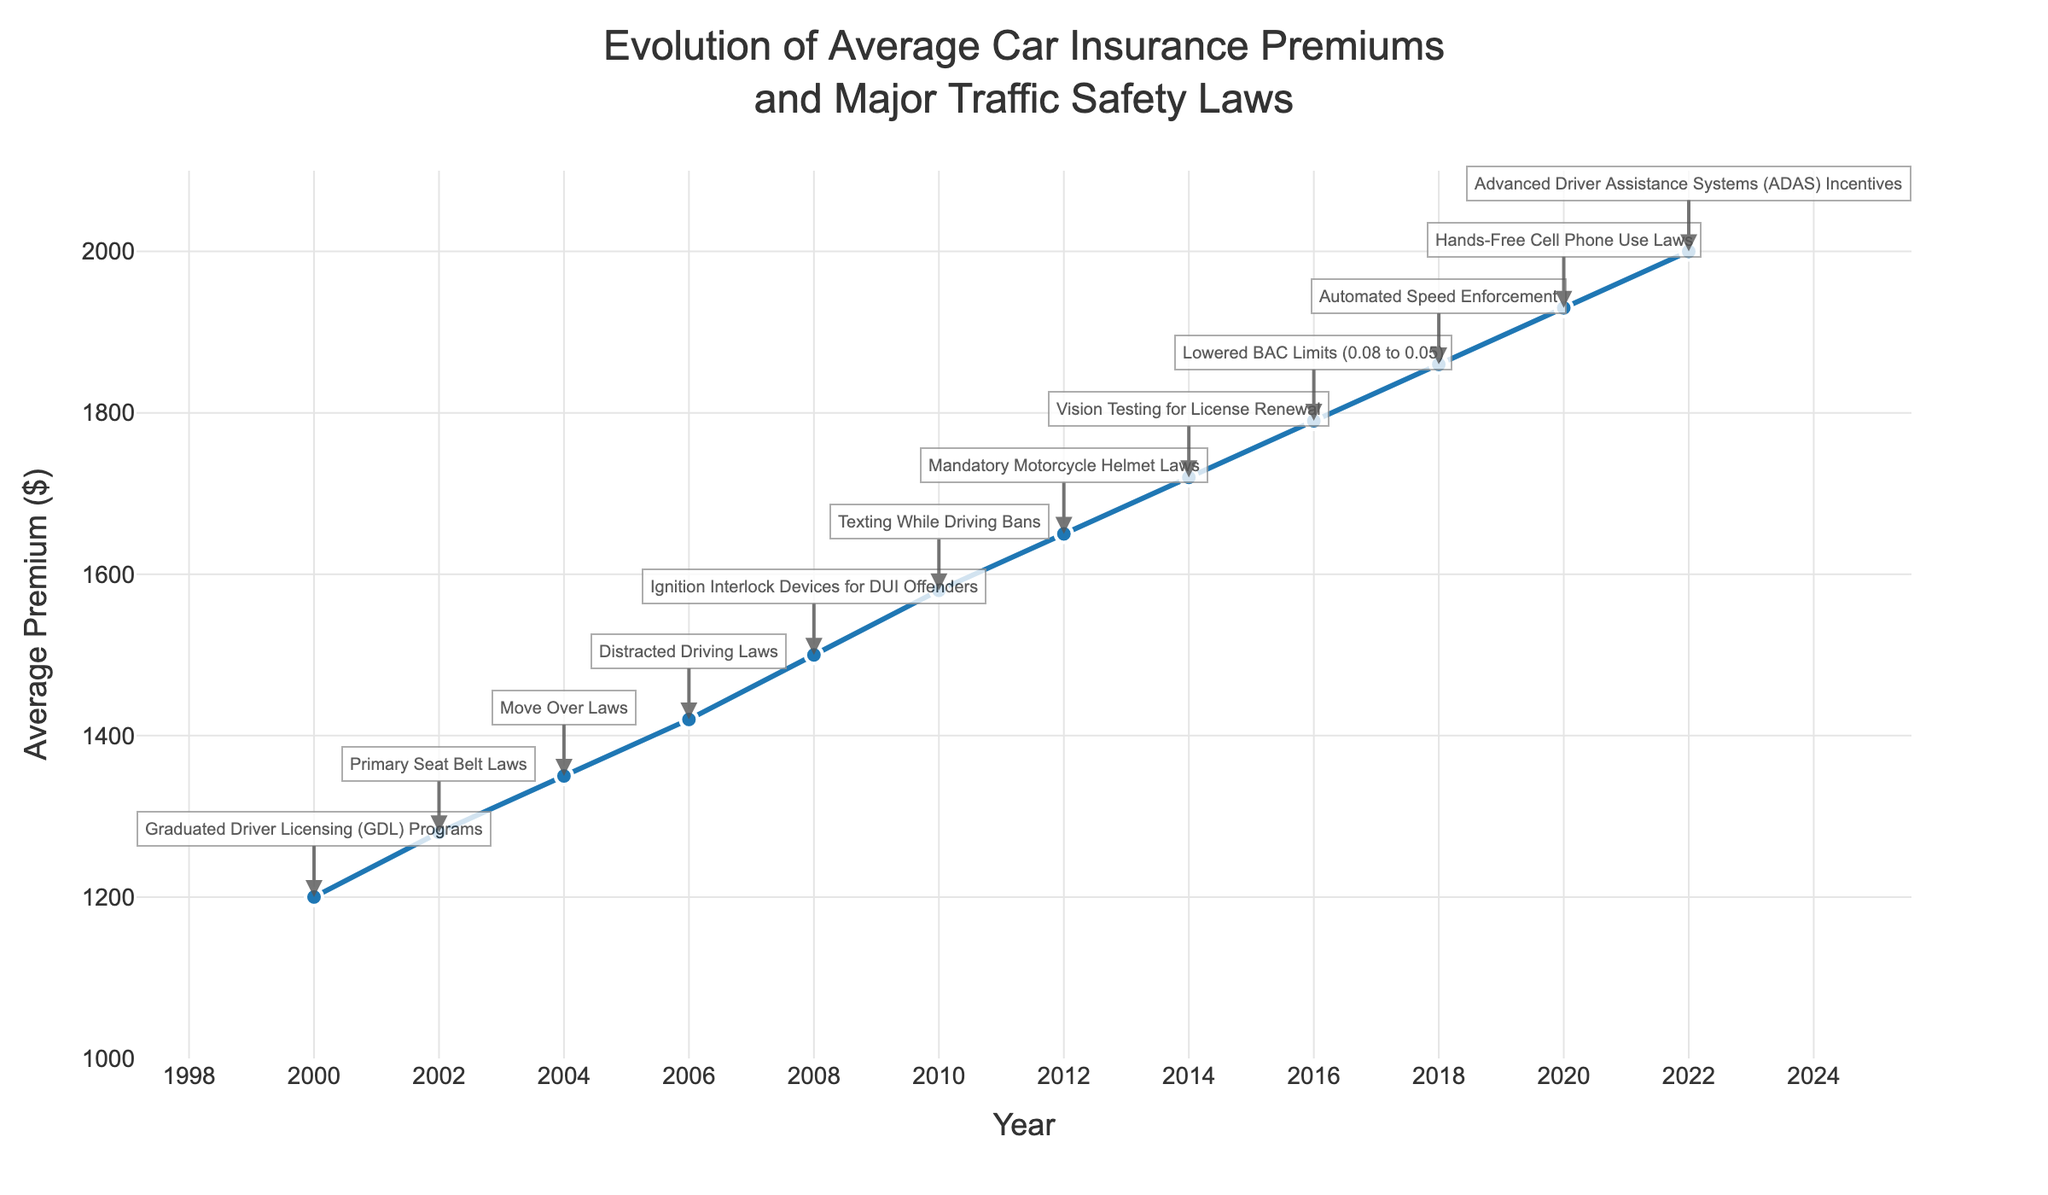Which year saw the highest average car insurance premium? The highest point on the Y-axis (Average Premium) corresponds to the year 2022, with an average premium of $2000.
Answer: 2022 By how much did the average premium increase between the year 2000 and 2022? Subtract the average premium in 2000 from the average premium in 2022. Thus, 2000 - 1200 = 800.
Answer: 800 Is there any year where the average premium decreased? By observing the continuous upward trend of the line, no year shows a decrease in average premium.
Answer: No Which traffic safety law was implemented when the average premium was $1500? The annotation near the $1500 mark indicates Ignition Interlock Devices for DUI Offenders, which was implemented in 2008.
Answer: Ignition Interlock Devices for DUI Offenders How did the average premium change after the implementation of Distracted Driving Laws in 2006? The premium increased from $1420 in 2006 to $1580 in 2010. Subtracting the 2006 premium from the 2010 premium, we get 1580 - 1420 = 160.
Answer: Increased by 160 Compare the average premiums between 2002 and 2004. Which year had a higher premium and by how much? The premium in 2002 was $1280, and in 2004, it was $1350. Subtracting the 2002 premium from the 2004 premium, we get 1350 - 1280 = 70. So, 2004 had a higher premium by 70.
Answer: 2004 by 70 What is the average premium over the entire period shown in the figure (2000 to 2022)? Sum up all the average premiums: 1200 + 1280 + 1350 + 1420 + 1500 + 1580 + 1650 + 1720 + 1790 + 1860 + 1930 + 2000 = 19280. Divide by the number of years (12): 19280 / 12 ≈ 1606.67
Answer: 1606.67 Which implemented traffic safety law coincides with a premium less than $1400? The annotations show that premiums less than $1400 are between 2000 and 2004. The 'Primary Seat Belt Laws' in 2002 (premium $1280) and 'Graduated Driver Licensing (GDL) Programs' in 2000 (premium $1200) fit this criterion.
Answer: Primary Seat Belt Laws, Graduated Driver Licensing (GDL) Programs 